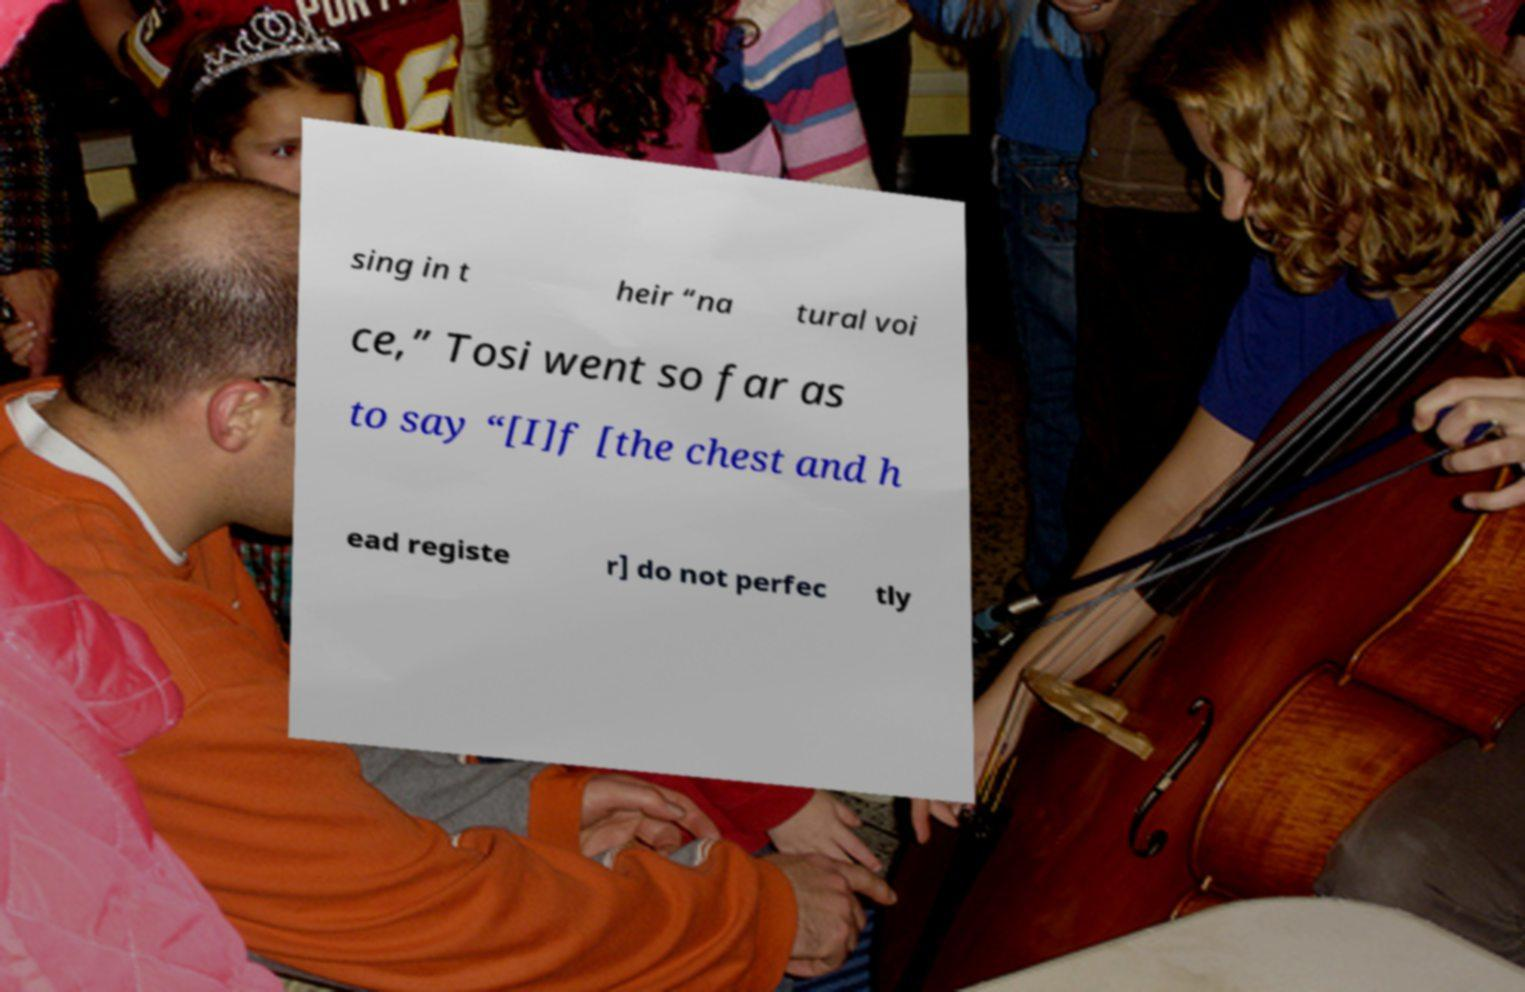Please identify and transcribe the text found in this image. sing in t heir “na tural voi ce,” Tosi went so far as to say “[I]f [the chest and h ead registe r] do not perfec tly 